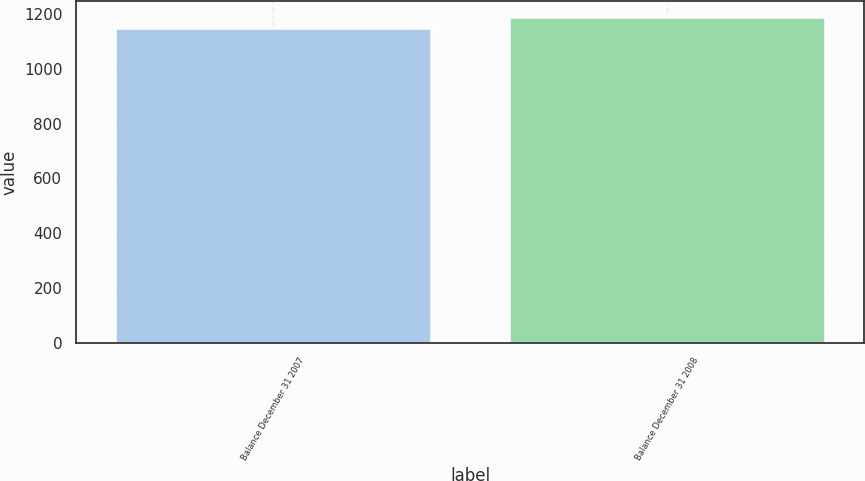<chart> <loc_0><loc_0><loc_500><loc_500><bar_chart><fcel>Balance December 31 2007<fcel>Balance December 31 2008<nl><fcel>1148<fcel>1189<nl></chart> 